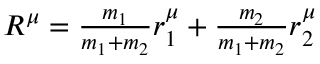<formula> <loc_0><loc_0><loc_500><loc_500>\begin{array} { r } { R ^ { \mu } = \frac { m _ { 1 } } { m _ { 1 } + m _ { 2 } } r _ { 1 } ^ { \mu } + \frac { m _ { 2 } } { m _ { 1 } + m _ { 2 } } r _ { 2 } ^ { \mu } } \end{array}</formula> 